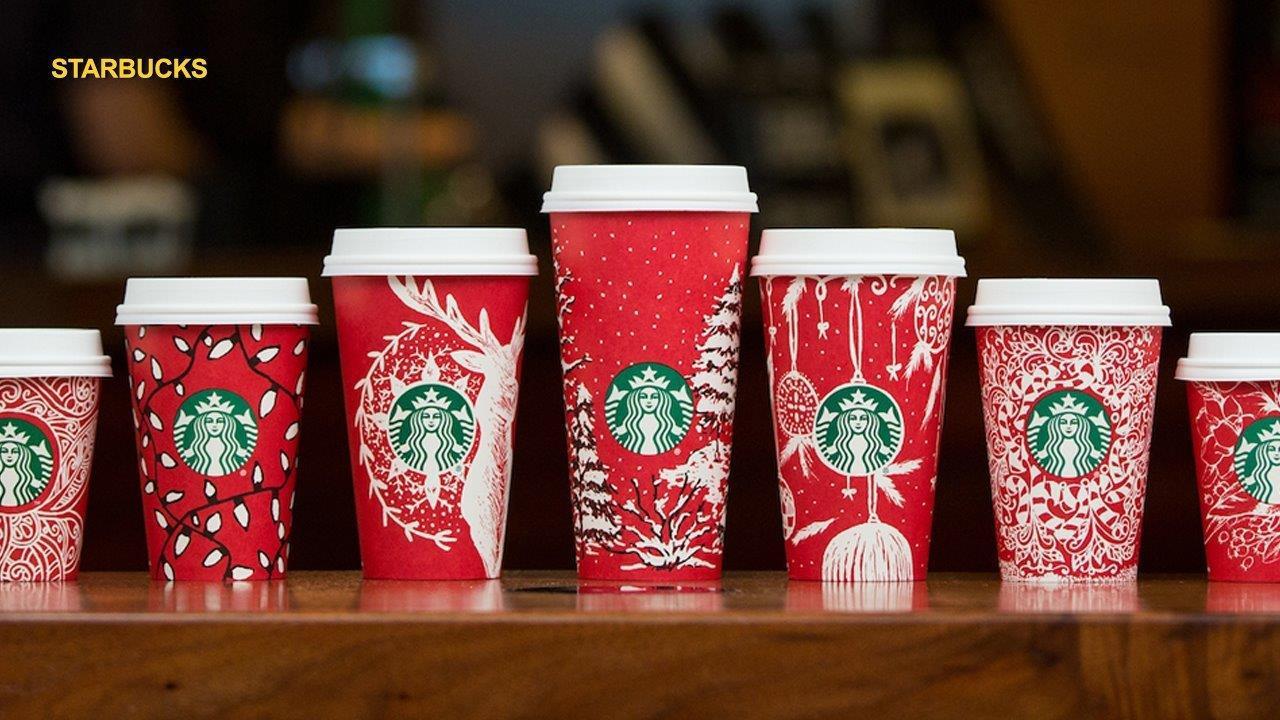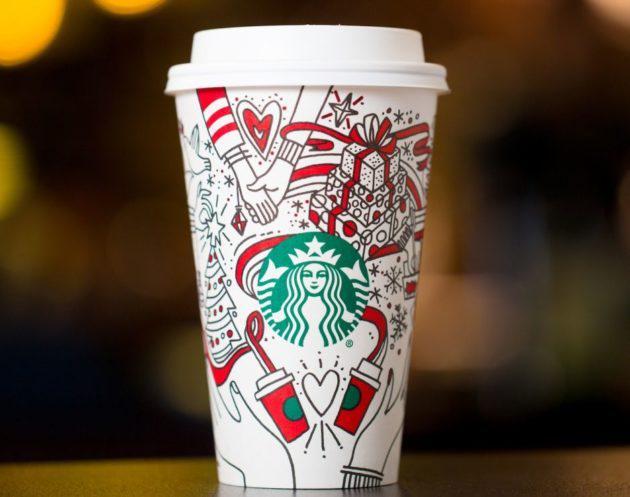The first image is the image on the left, the second image is the image on the right. Evaluate the accuracy of this statement regarding the images: "There is a single cup in one of the images.". Is it true? Answer yes or no. Yes. The first image is the image on the left, the second image is the image on the right. Assess this claim about the two images: "At least one image includes a white cup with a lid on it and an illustration of holding hands on its front.". Correct or not? Answer yes or no. Yes. 